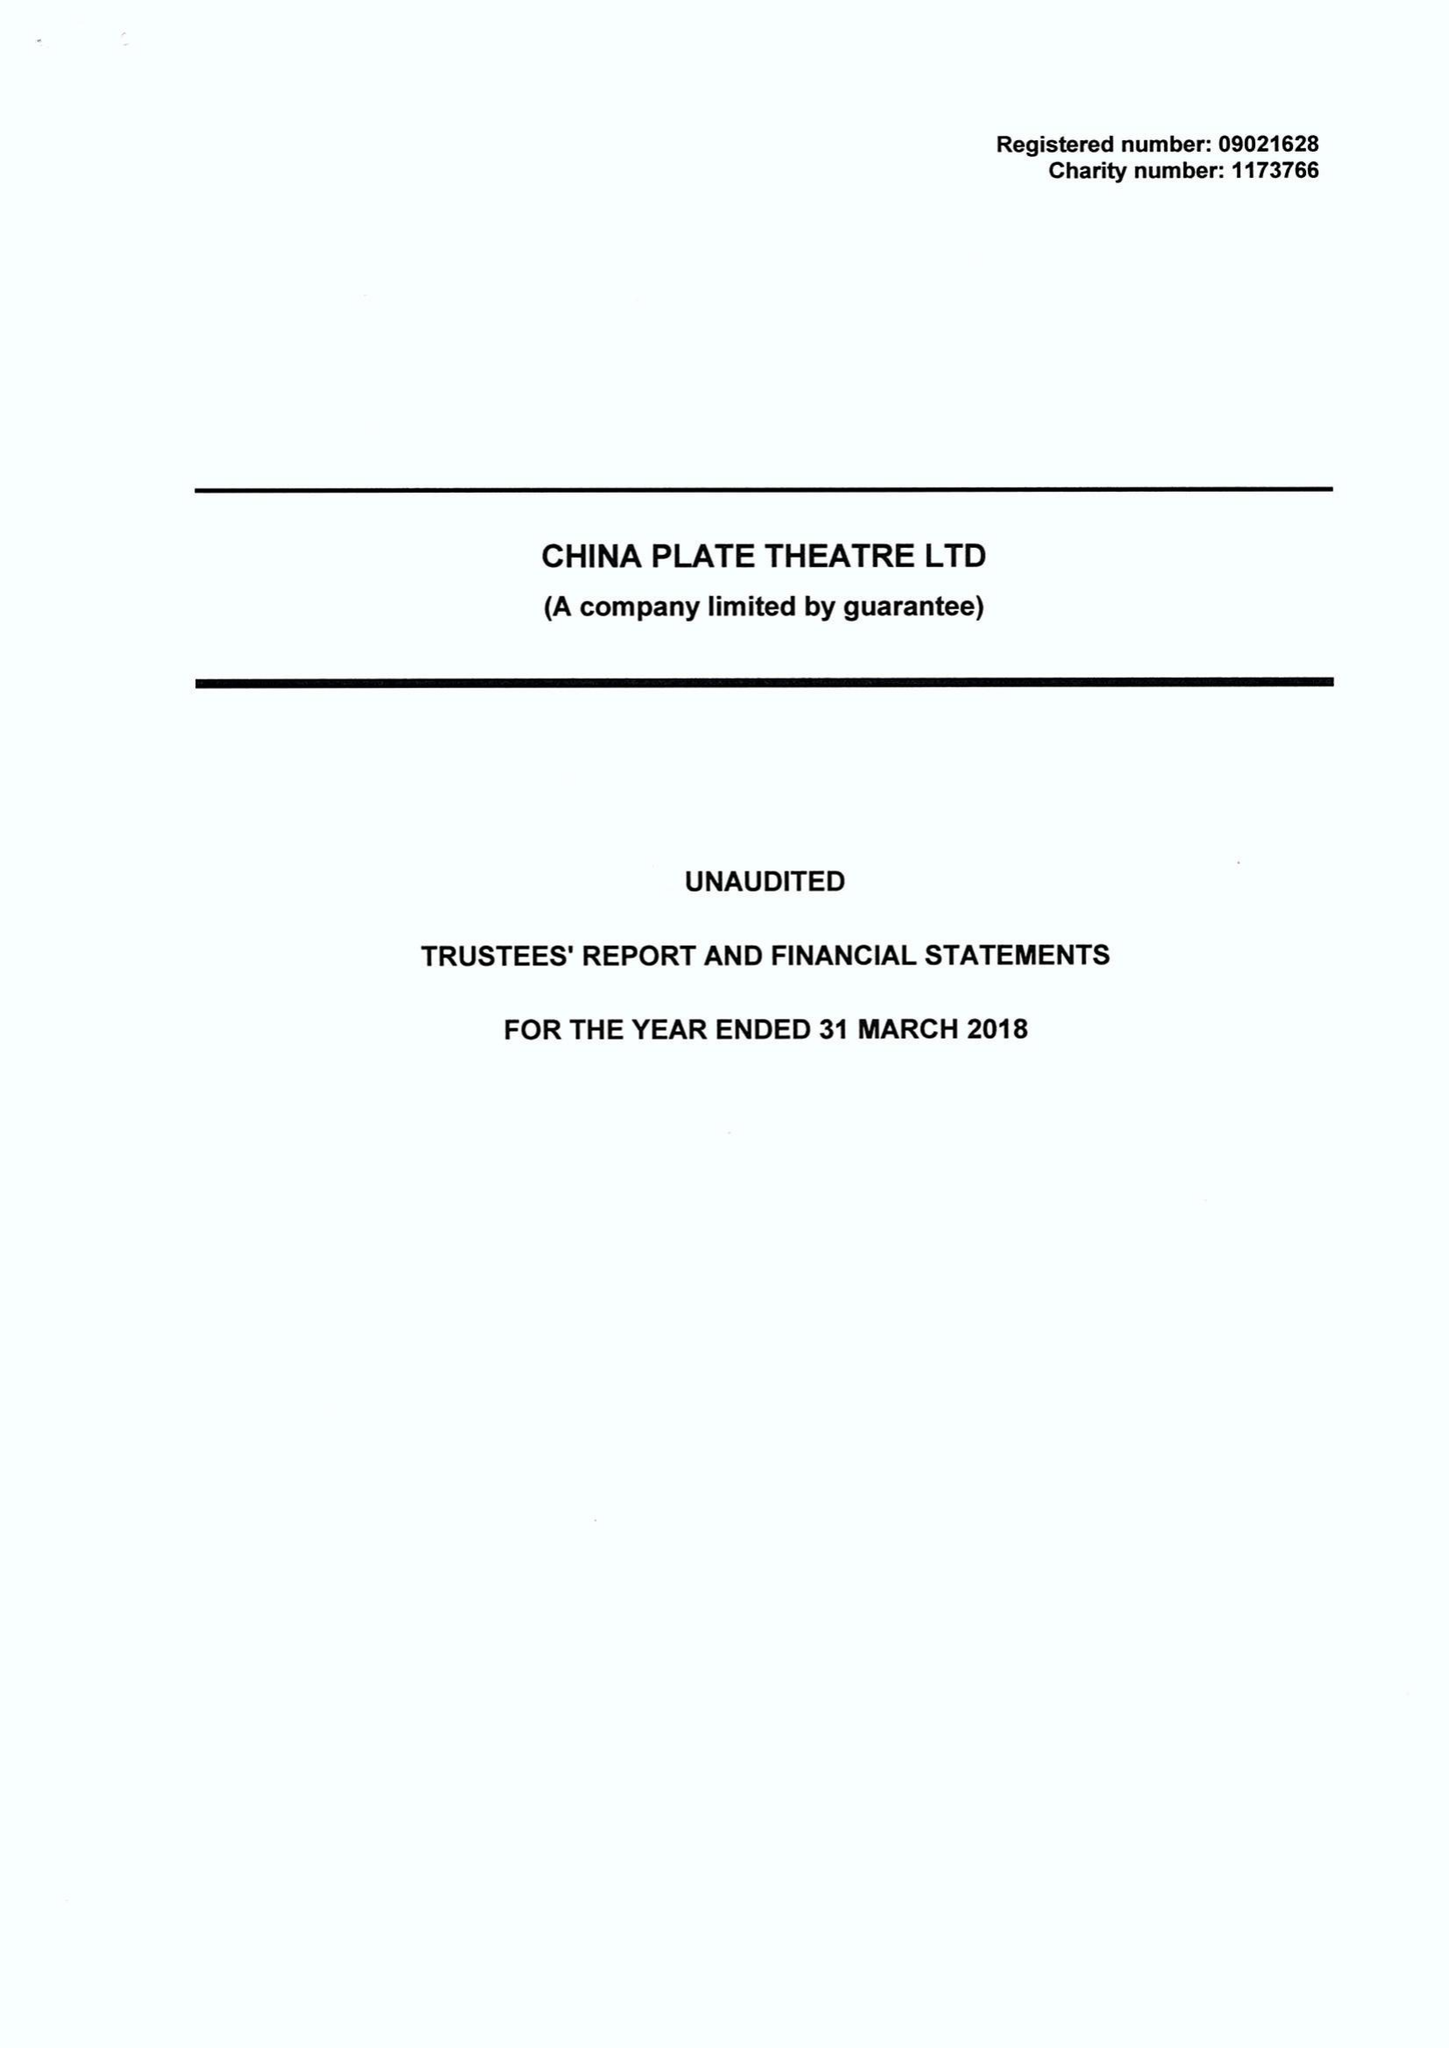What is the value for the income_annually_in_british_pounds?
Answer the question using a single word or phrase. 479837.00 